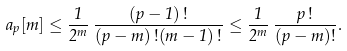<formula> <loc_0><loc_0><loc_500><loc_500>a _ { p } [ m ] \leq \frac { 1 } { 2 ^ { m } } \, \frac { ( p - 1 ) \, ! } { ( p - m ) \, ! ( m - 1 ) \, ! } \leq \frac { 1 } { 2 ^ { m } } \, \frac { p \, ! } { ( p - m ) ! } .</formula> 